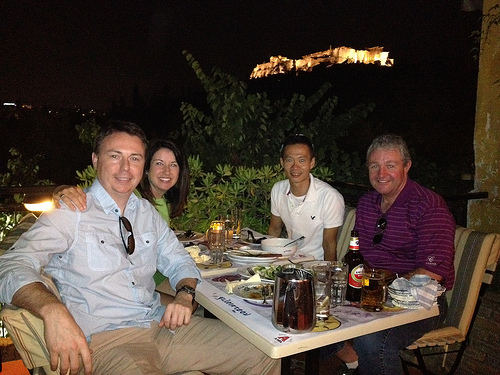What are the people eating and drinking? There are glasses that might contain beer or another amber colored beverage, and it seems they are having a variety of dishes, possibly local cuisine. 